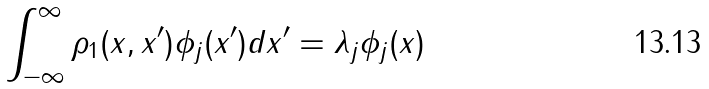Convert formula to latex. <formula><loc_0><loc_0><loc_500><loc_500>\int _ { - \infty } ^ { \infty } \rho _ { 1 } ( x , x ^ { \prime } ) \phi _ { j } ( x ^ { \prime } ) d x ^ { \prime } = \lambda _ { j } \phi _ { j } ( x )</formula> 